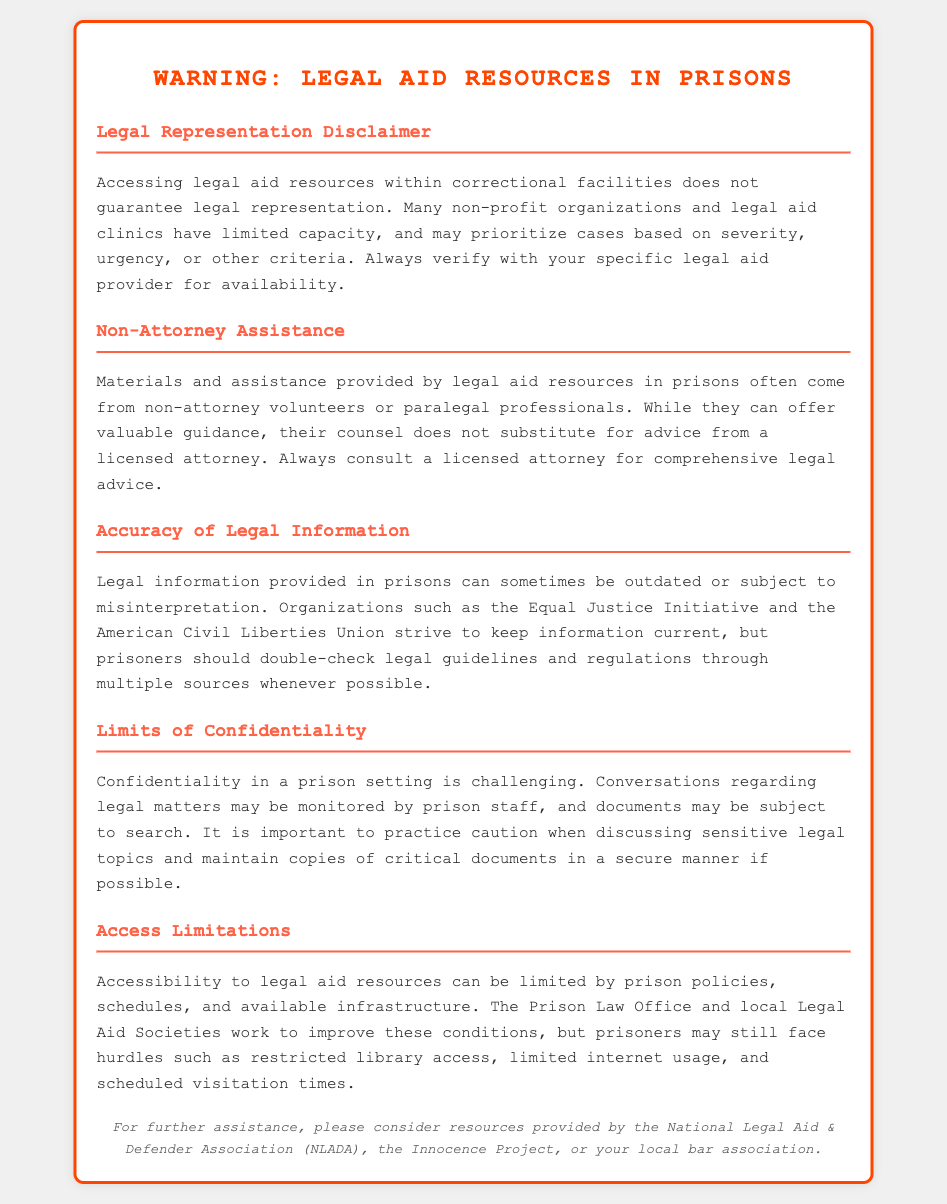What is the title of the document? The title is provided in the header section of the document, which is "Warning: Legal Aid Resources in Prisons."
Answer: Warning: Legal Aid Resources in Prisons What type of professionals provide assistance within prisons? This question relates to the section that discusses the types of individuals who offer guidance, specifically mentioning non-attorney volunteers and paralegals.
Answer: Non-attorney volunteers or paralegal professionals What organization is mentioned for legal information accuracy? The document points out specific organizations that strive to keep legal information current, one of which is named.
Answer: Equal Justice Initiative What is a significant limitation regarding confidentiality in prison? This question focuses on the document's mention of confidentiality issues related to legal matters in a prison setting.
Answer: Conversations may be monitored Who might prioritize cases based on urgency? This relates to the description regarding who may have limited capacity in legal aid, emphasizing the organizations that provide this support.
Answer: Non-profit organizations and legal aid clinics What is an example of a limitation prisoners may face for accessing legal resources? The document lists specific barriers that prisoners encounter when trying to access legal aid resources.
Answer: Restricted library access 